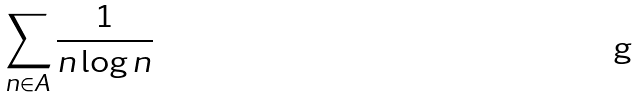Convert formula to latex. <formula><loc_0><loc_0><loc_500><loc_500>\sum _ { n \in A } \frac { 1 } { n \log n }</formula> 